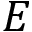Convert formula to latex. <formula><loc_0><loc_0><loc_500><loc_500>E</formula> 